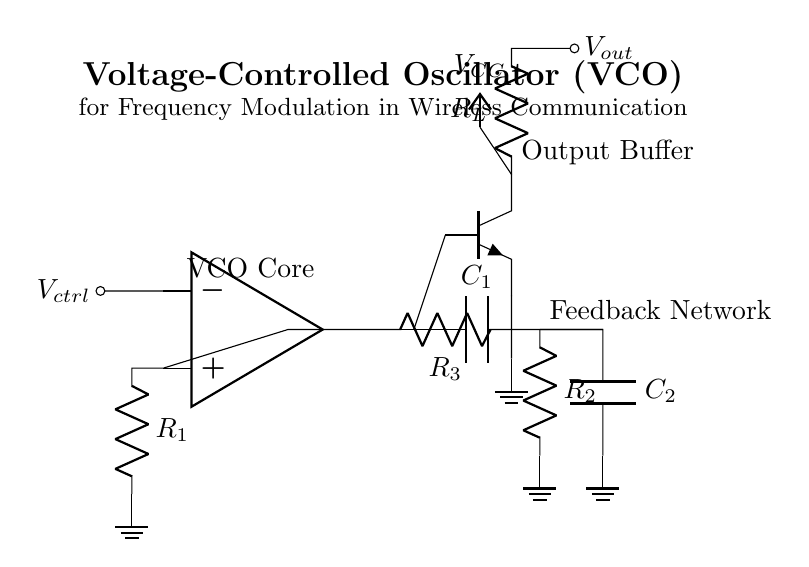What is the type of oscillator depicted in the circuit? The circuit is a voltage-controlled oscillator, which is indicated by the label and the configuration of the components that allow for frequency modulation based on the control voltage.
Answer: voltage-controlled oscillator What is the purpose of the component labeled R1? R1 is part of the VCO core and is used to set the gain of the operational amplifier, which in turn influences the oscillation frequency of the circuit based on feedback.
Answer: gain setting What component is responsible for frequency modulation? The feedback network consisting of capacitors and resistors modifies the oscillation frequency based on the control voltage applied.
Answer: feedback network How many capacitors are present in the feedback network? There are two capacitors labeled C1 and C2 connected in the feedback network, as indicated in the diagram showing their connections and placements.
Answer: two What role does the output buffer play in this circuit? The output buffer amplifies the output signal from the VCO core, providing a stronger signal that can drive loads or be sent to other parts of the communication system without significant loading effects.
Answer: signal amplification What is the output voltage represented as in the circuit? The output voltage is represented as Vout, which is shown at the output of the buffer and indicated by the source that delivers the final oscillation signal to external circuitry.
Answer: Vout 